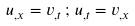<formula> <loc_0><loc_0><loc_500><loc_500>u _ { , x } = v _ { , t } \, ; \, u _ { , t } = v _ { , x }</formula> 